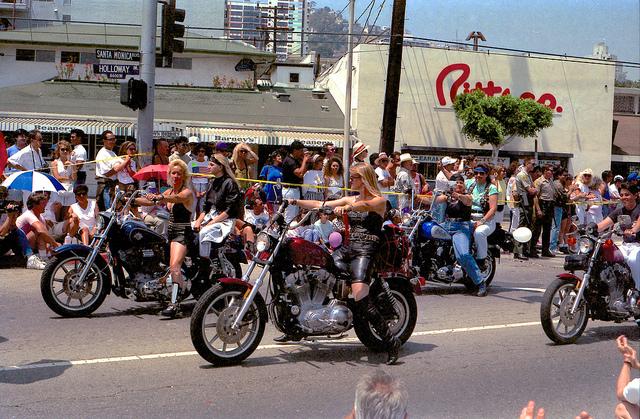How many motorcycles on the street?
Keep it brief. 4. Is this a bike show?
Concise answer only. Yes. How many girls are on bikes?
Write a very short answer. 4. 